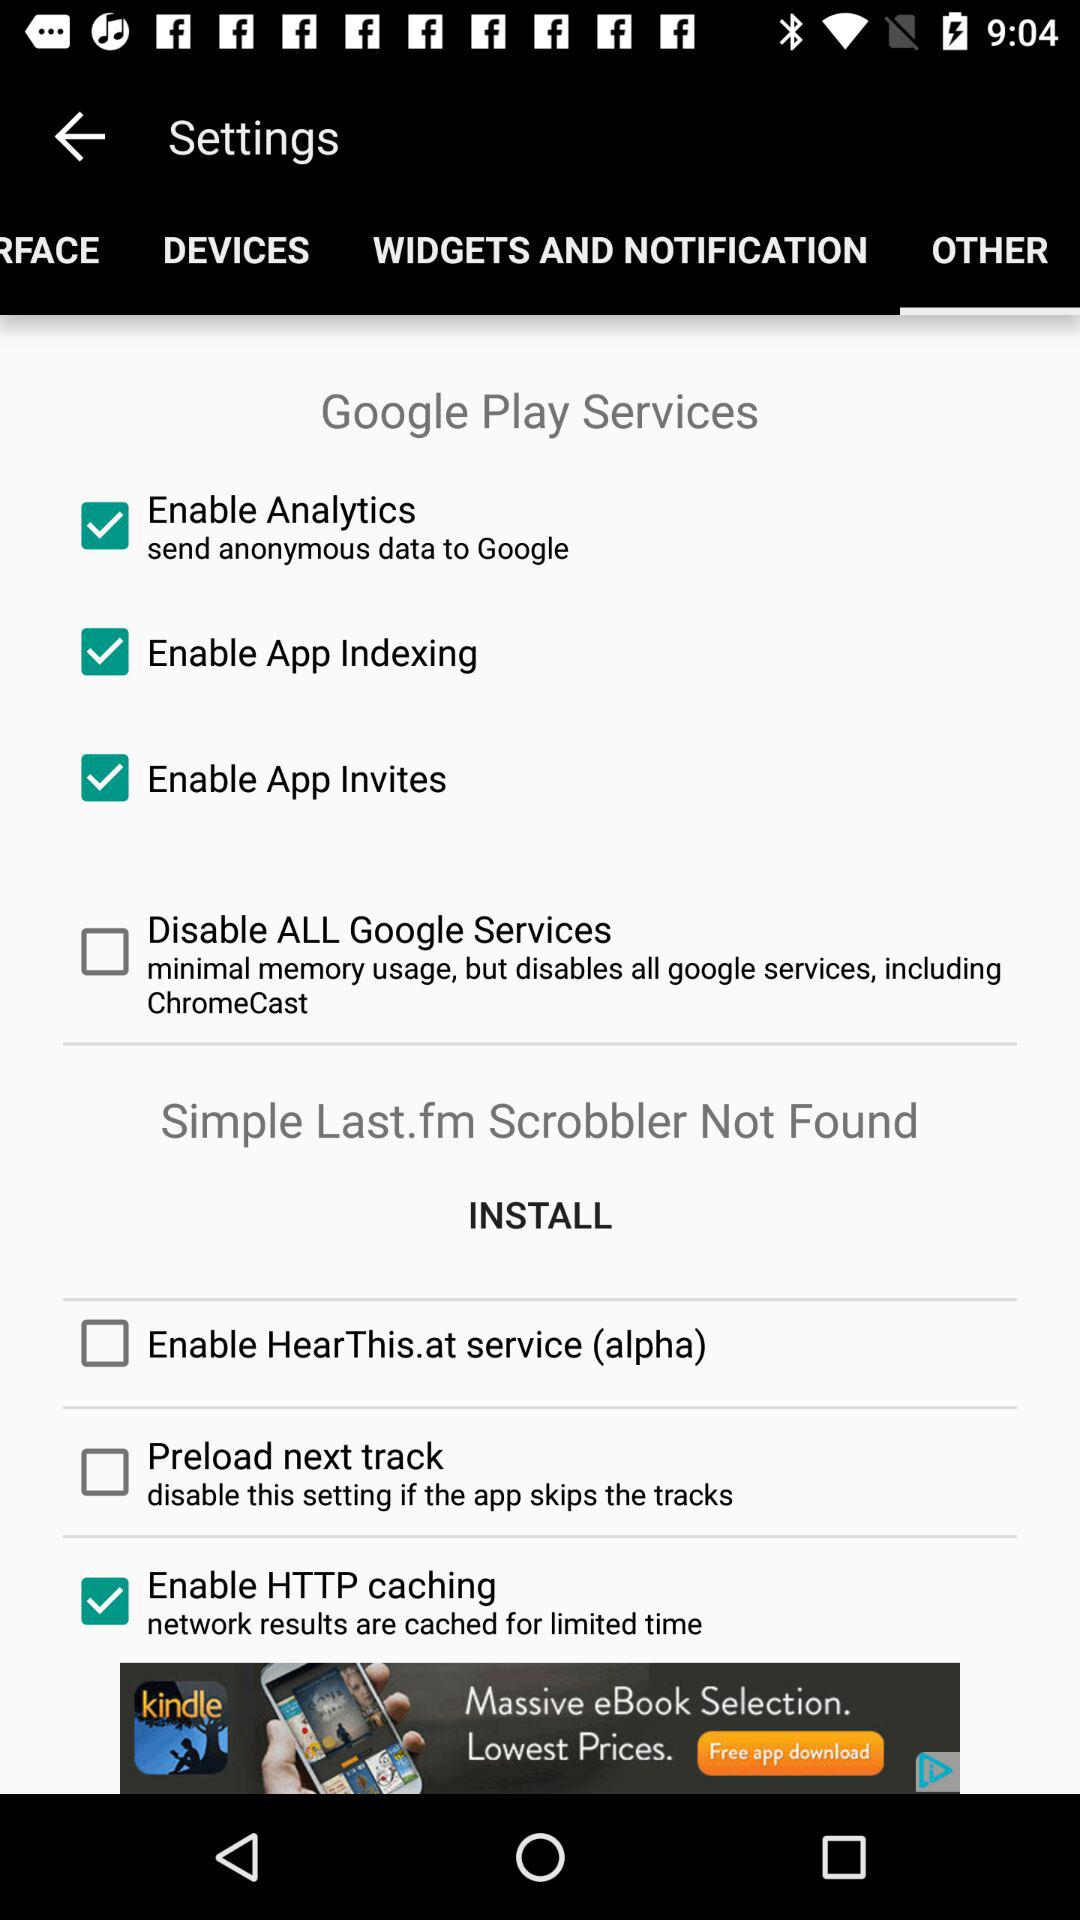What is the current state of "Preload next track"? The current state of "Preload next track" is "off". 